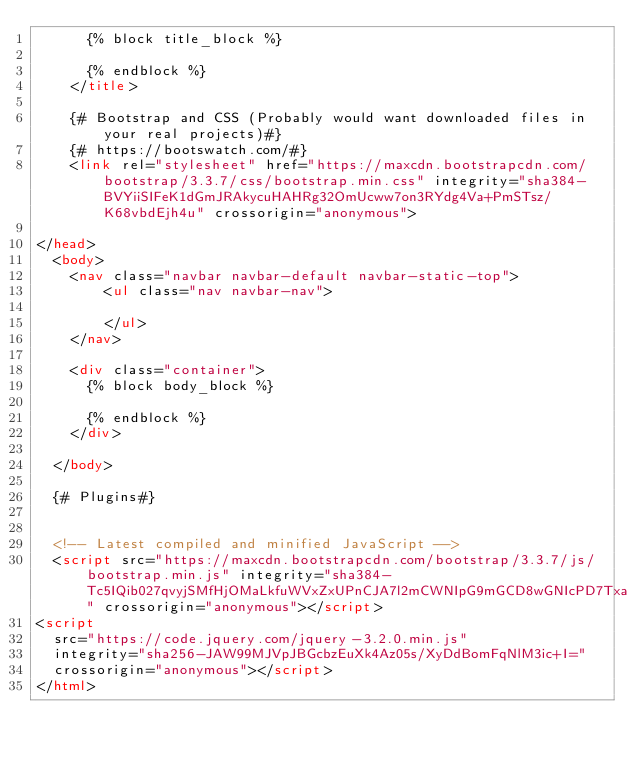<code> <loc_0><loc_0><loc_500><loc_500><_HTML_>      {% block title_block %}

      {% endblock %}
    </title>

    {# Bootstrap and CSS (Probably would want downloaded files in your real projects)#}
    {# https://bootswatch.com/#}
    <link rel="stylesheet" href="https://maxcdn.bootstrapcdn.com/bootstrap/3.3.7/css/bootstrap.min.css" integrity="sha384-BVYiiSIFeK1dGmJRAkycuHAHRg32OmUcww7on3RYdg4Va+PmSTsz/K68vbdEjh4u" crossorigin="anonymous">

</head>
  <body>
    <nav class="navbar navbar-default navbar-static-top">
        <ul class="nav navbar-nav">
          
        </ul>
    </nav>

    <div class="container">
      {% block body_block %}

      {% endblock %}
    </div>

  </body>

  {# Plugins#}


  <!-- Latest compiled and minified JavaScript -->
  <script src="https://maxcdn.bootstrapcdn.com/bootstrap/3.3.7/js/bootstrap.min.js" integrity="sha384-Tc5IQib027qvyjSMfHjOMaLkfuWVxZxUPnCJA7l2mCWNIpG9mGCD8wGNIcPD7Txa" crossorigin="anonymous"></script>
<script
  src="https://code.jquery.com/jquery-3.2.0.min.js"
  integrity="sha256-JAW99MJVpJBGcbzEuXk4Az05s/XyDdBomFqNlM3ic+I="
  crossorigin="anonymous"></script>
</html>
</code> 